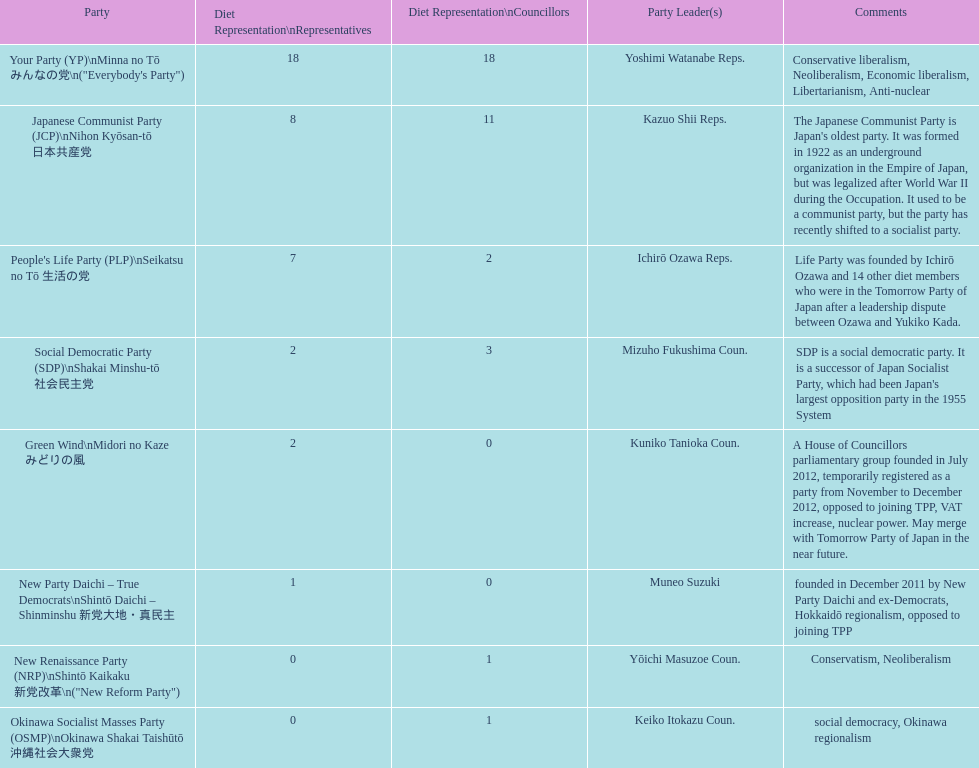What party is listed previous to the new renaissance party? New Party Daichi - True Democrats. 